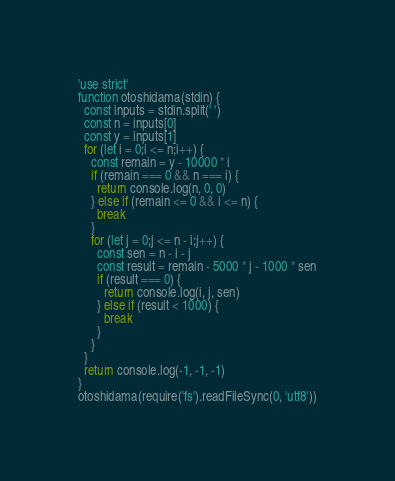Convert code to text. <code><loc_0><loc_0><loc_500><loc_500><_JavaScript_>'use strict'
function otoshidama(stdin) {
  const inputs = stdin.split(' ')
  const n = inputs[0]
  const y = inputs[1]
  for (let i = 0;i <= n;i++) {
    const remain = y - 10000 * i
    if (remain === 0 && n === i) {
      return console.log(n, 0, 0)
    } else if (remain <= 0 && i <= n) {
      break
    }
    for (let j = 0;j <= n - i;j++) {
      const sen = n - i - j
      const result = remain - 5000 * j - 1000 * sen
      if (result === 0) {
        return console.log(i, j, sen)
      } else if (result < 1000) {
        break
      }
    }
  }
  return console.log(-1, -1, -1)
}
otoshidama(require('fs').readFileSync(0, 'utf8'))</code> 